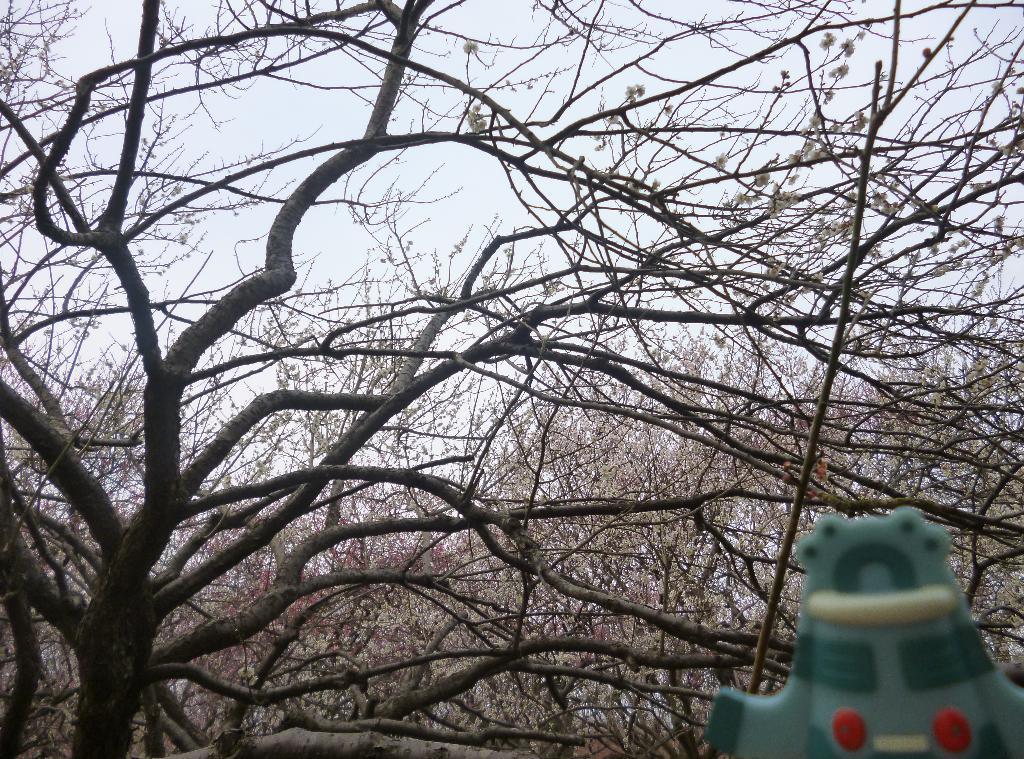Please provide a concise description of this image. In this image, I can see the trees. At the bottom right side of the image, that looks like an object, which is green in color. 